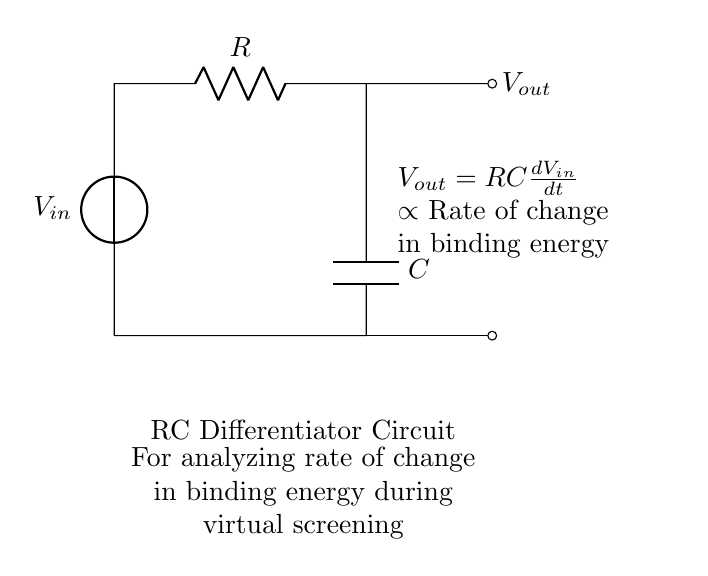What is the input voltage source labeled as? The input voltage source is labeled as "V_in," which stands for the voltage input to the circuit.
Answer: V_in What component is connected in series with the input voltage source? A resistor "R" is connected in series with the input voltage source "V_in," indicating the first component in the circuit after the source.
Answer: R What is the function of the capacitor in this circuit? The capacitor "C" serves to differentiate the voltage input; it allows the circuit to react to changes in voltage over time, contributing to the output related to the rate of change of binding energy.
Answer: Differentiation What is the formula for the output voltage? The output voltage "V_out" is given by the equation "V_out = RC(dV_in/dt)," indicating that it is proportional to the product of resistance, capacitance, and the rate of change of input voltage.
Answer: V_out = RC(dV_in/dt) How does the output voltage relate to binding energy? The output voltage "V_out" is proportional to the rate of change in binding energy during virtual screening, meaning as the binding energy changes quickly, the output voltage increases correspondingly.
Answer: Proportional relationship What type of circuit is represented here? This is an RC differentiator circuit, which specifically describes its configuration designed to differentiate voltage signals.
Answer: RC differentiator What are the output terminals labeled as? The output terminals are labeled as "V_out," representing the output voltage of the circuit.
Answer: V_out 